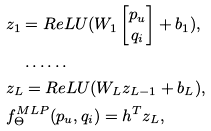<formula> <loc_0><loc_0><loc_500><loc_500>& z _ { 1 } = R e L U ( W _ { 1 } \begin{bmatrix} p _ { u } \\ q _ { i } \\ \end{bmatrix} + b _ { 1 } ) , \\ & \quad \dots \dots \\ & z _ { L } = R e L U ( W _ { L } z _ { L - 1 } + b _ { L } ) , \\ & f _ { \Theta } ^ { M L P } ( p _ { u } , q _ { i } ) = h ^ { T } z _ { L } ,</formula> 